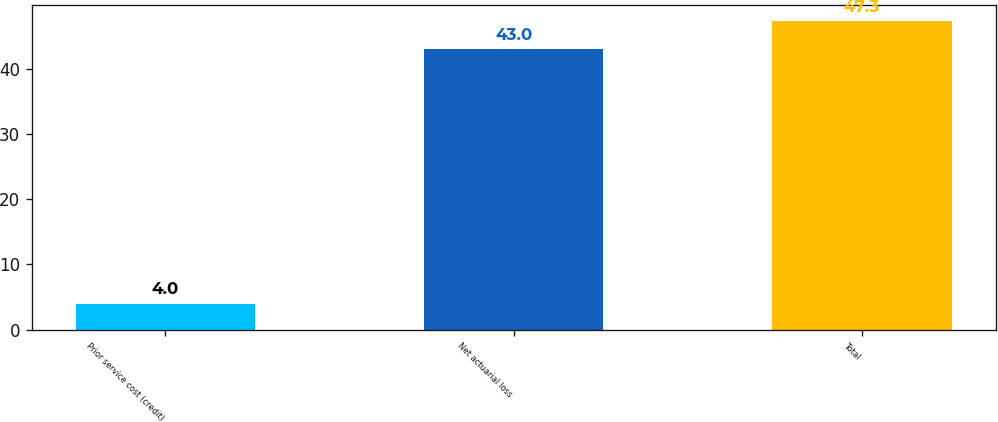Convert chart. <chart><loc_0><loc_0><loc_500><loc_500><bar_chart><fcel>Prior service cost (credit)<fcel>Net actuarial loss<fcel>Total<nl><fcel>4<fcel>43<fcel>47.3<nl></chart> 